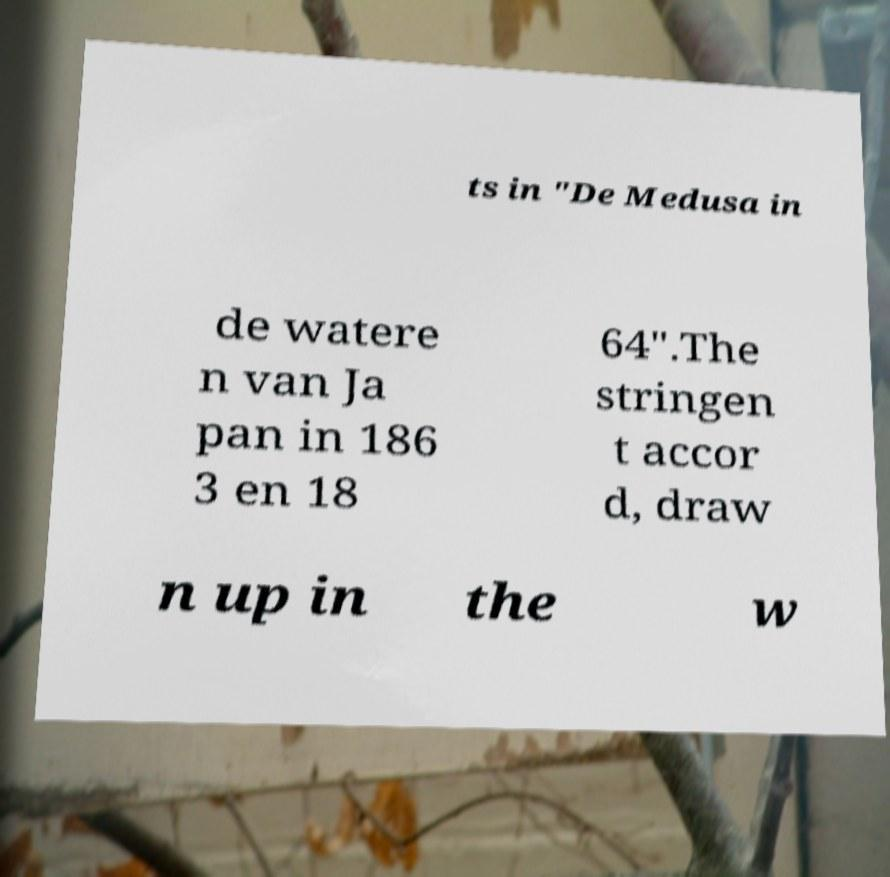What messages or text are displayed in this image? I need them in a readable, typed format. ts in "De Medusa in de watere n van Ja pan in 186 3 en 18 64".The stringen t accor d, draw n up in the w 